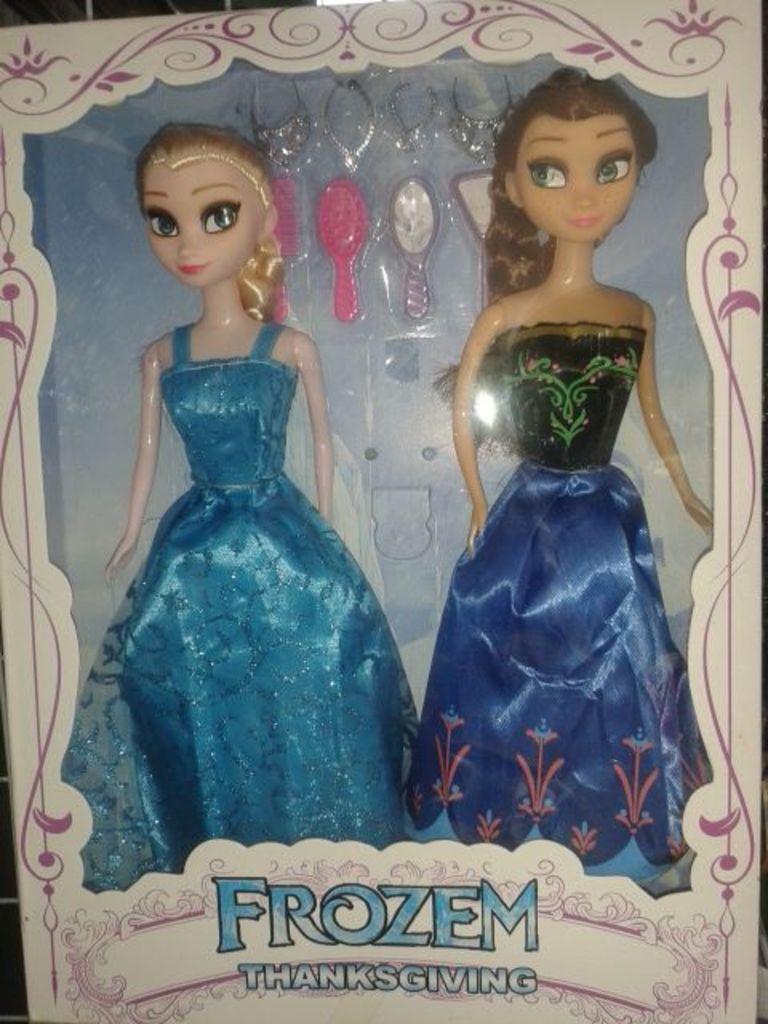How would you summarize this image in a sentence or two? In this image there are dolls and there is some text written on the cover of the doll. 